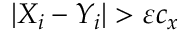Convert formula to latex. <formula><loc_0><loc_0><loc_500><loc_500>| X _ { i } - Y _ { i } | > \varepsilon c _ { x }</formula> 